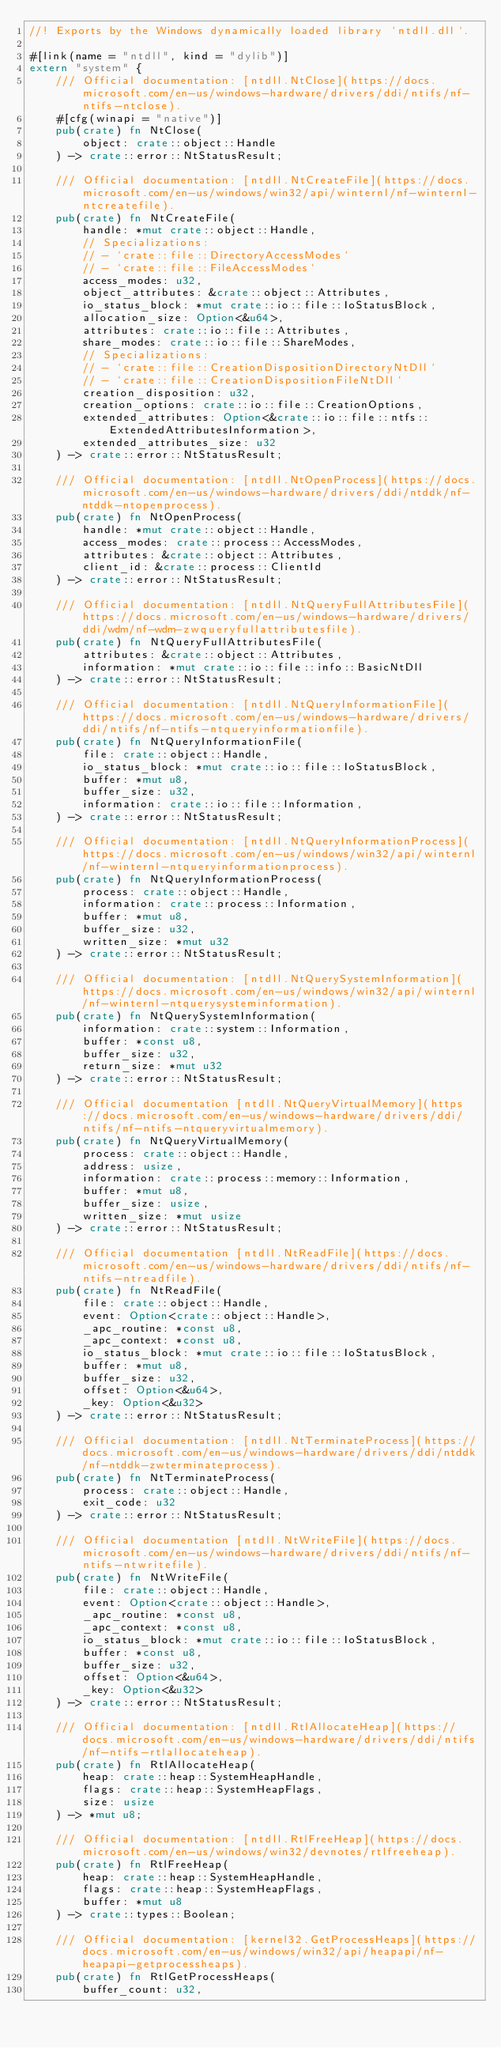Convert code to text. <code><loc_0><loc_0><loc_500><loc_500><_Rust_>//! Exports by the Windows dynamically loaded library `ntdll.dll`.

#[link(name = "ntdll", kind = "dylib")]
extern "system" {
    /// Official documentation: [ntdll.NtClose](https://docs.microsoft.com/en-us/windows-hardware/drivers/ddi/ntifs/nf-ntifs-ntclose).
    #[cfg(winapi = "native")]
    pub(crate) fn NtClose(
        object: crate::object::Handle
    ) -> crate::error::NtStatusResult;

    /// Official documentation: [ntdll.NtCreateFile](https://docs.microsoft.com/en-us/windows/win32/api/winternl/nf-winternl-ntcreatefile).
    pub(crate) fn NtCreateFile(
        handle: *mut crate::object::Handle,
        // Specializations:
        // - `crate::file::DirectoryAccessModes`
        // - `crate::file::FileAccessModes`
        access_modes: u32,
        object_attributes: &crate::object::Attributes,
        io_status_block: *mut crate::io::file::IoStatusBlock,
        allocation_size: Option<&u64>,
        attributes: crate::io::file::Attributes,
        share_modes: crate::io::file::ShareModes,
        // Specializations:
        // - `crate::file::CreationDispositionDirectoryNtDll`
        // - `crate::file::CreationDispositionFileNtDll`
        creation_disposition: u32,
        creation_options: crate::io::file::CreationOptions,
        extended_attributes: Option<&crate::io::file::ntfs::ExtendedAttributesInformation>,
        extended_attributes_size: u32
    ) -> crate::error::NtStatusResult;

    /// Official documentation: [ntdll.NtOpenProcess](https://docs.microsoft.com/en-us/windows-hardware/drivers/ddi/ntddk/nf-ntddk-ntopenprocess).
    pub(crate) fn NtOpenProcess(
        handle: *mut crate::object::Handle,
        access_modes: crate::process::AccessModes,
        attributes: &crate::object::Attributes,
        client_id: &crate::process::ClientId
    ) -> crate::error::NtStatusResult;

    /// Official documentation: [ntdll.NtQueryFullAttributesFile](https://docs.microsoft.com/en-us/windows-hardware/drivers/ddi/wdm/nf-wdm-zwqueryfullattributesfile).
    pub(crate) fn NtQueryFullAttributesFile(
        attributes: &crate::object::Attributes,
        information: *mut crate::io::file::info::BasicNtDll
    ) -> crate::error::NtStatusResult;

    /// Official documentation: [ntdll.NtQueryInformationFile](https://docs.microsoft.com/en-us/windows-hardware/drivers/ddi/ntifs/nf-ntifs-ntqueryinformationfile).
    pub(crate) fn NtQueryInformationFile(
        file: crate::object::Handle,
        io_status_block: *mut crate::io::file::IoStatusBlock,
        buffer: *mut u8,
        buffer_size: u32,
        information: crate::io::file::Information,
    ) -> crate::error::NtStatusResult;

    /// Official documentation: [ntdll.NtQueryInformationProcess](https://docs.microsoft.com/en-us/windows/win32/api/winternl/nf-winternl-ntqueryinformationprocess).
    pub(crate) fn NtQueryInformationProcess(
        process: crate::object::Handle,
        information: crate::process::Information,
        buffer: *mut u8,
        buffer_size: u32,
        written_size: *mut u32
    ) -> crate::error::NtStatusResult;

    /// Official documentation: [ntdll.NtQuerySystemInformation](https://docs.microsoft.com/en-us/windows/win32/api/winternl/nf-winternl-ntquerysysteminformation).
    pub(crate) fn NtQuerySystemInformation(
        information: crate::system::Information,
        buffer: *const u8,
        buffer_size: u32,
        return_size: *mut u32
    ) -> crate::error::NtStatusResult;

    /// Official documentation [ntdll.NtQueryVirtualMemory](https://docs.microsoft.com/en-us/windows-hardware/drivers/ddi/ntifs/nf-ntifs-ntqueryvirtualmemory).
    pub(crate) fn NtQueryVirtualMemory(
        process: crate::object::Handle,
        address: usize,
        information: crate::process::memory::Information,
        buffer: *mut u8,
        buffer_size: usize,
        written_size: *mut usize
    ) -> crate::error::NtStatusResult;

    /// Official documentation [ntdll.NtReadFile](https://docs.microsoft.com/en-us/windows-hardware/drivers/ddi/ntifs/nf-ntifs-ntreadfile).
    pub(crate) fn NtReadFile(
        file: crate::object::Handle,
        event: Option<crate::object::Handle>,
        _apc_routine: *const u8,
        _apc_context: *const u8,
        io_status_block: *mut crate::io::file::IoStatusBlock,
        buffer: *mut u8,
        buffer_size: u32,
        offset: Option<&u64>,
        _key: Option<&u32>
    ) -> crate::error::NtStatusResult;

    /// Official documentation: [ntdll.NtTerminateProcess](https://docs.microsoft.com/en-us/windows-hardware/drivers/ddi/ntddk/nf-ntddk-zwterminateprocess).
    pub(crate) fn NtTerminateProcess(
        process: crate::object::Handle,
        exit_code: u32
    ) -> crate::error::NtStatusResult;

    /// Official documentation [ntdll.NtWriteFile](https://docs.microsoft.com/en-us/windows-hardware/drivers/ddi/ntifs/nf-ntifs-ntwritefile).
    pub(crate) fn NtWriteFile(
        file: crate::object::Handle,
        event: Option<crate::object::Handle>,
        _apc_routine: *const u8,
        _apc_context: *const u8,
        io_status_block: *mut crate::io::file::IoStatusBlock,
        buffer: *const u8,
        buffer_size: u32,
        offset: Option<&u64>,
        _key: Option<&u32>
    ) -> crate::error::NtStatusResult;

    /// Official documentation: [ntdll.RtlAllocateHeap](https://docs.microsoft.com/en-us/windows-hardware/drivers/ddi/ntifs/nf-ntifs-rtlallocateheap).
    pub(crate) fn RtlAllocateHeap(
        heap: crate::heap::SystemHeapHandle,
        flags: crate::heap::SystemHeapFlags,
        size: usize
    ) -> *mut u8;

    /// Official documentation: [ntdll.RtlFreeHeap](https://docs.microsoft.com/en-us/windows/win32/devnotes/rtlfreeheap).
    pub(crate) fn RtlFreeHeap(
        heap: crate::heap::SystemHeapHandle,
        flags: crate::heap::SystemHeapFlags,
        buffer: *mut u8
    ) -> crate::types::Boolean;

    /// Official documentation: [kernel32.GetProcessHeaps](https://docs.microsoft.com/en-us/windows/win32/api/heapapi/nf-heapapi-getprocessheaps).
    pub(crate) fn RtlGetProcessHeaps(
        buffer_count: u32,</code> 